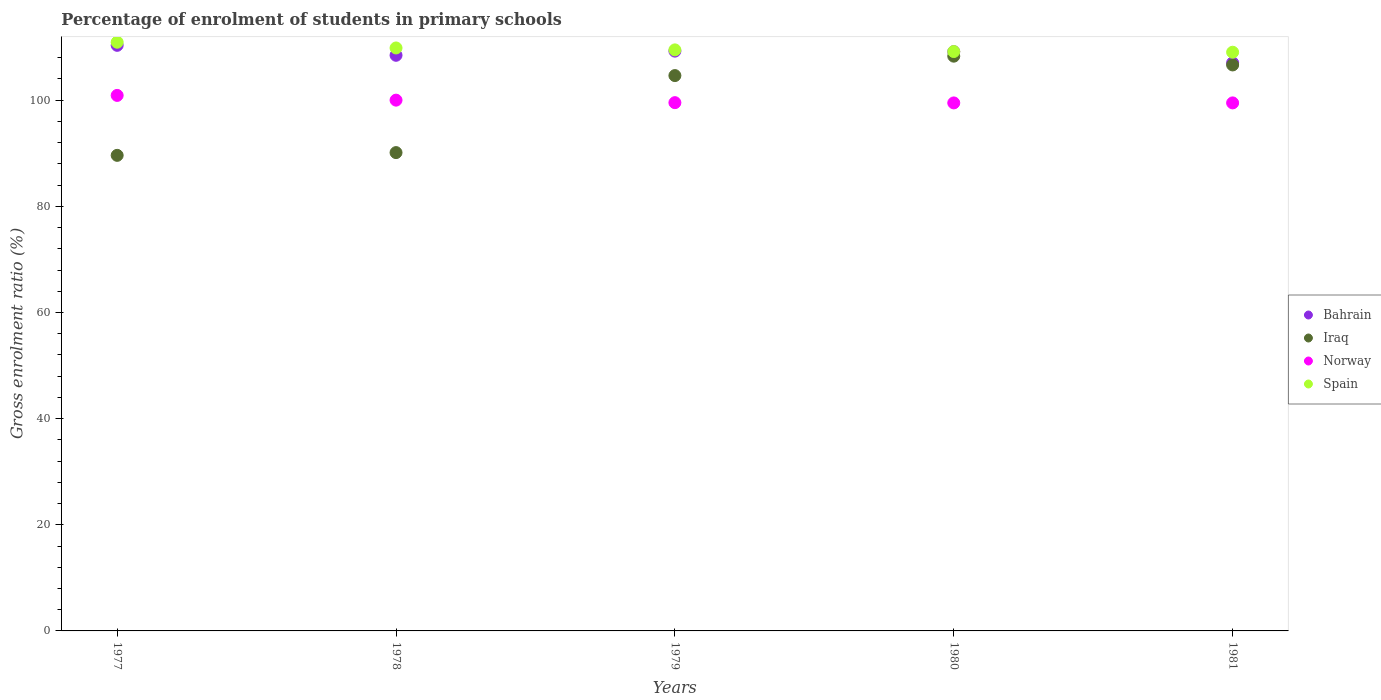What is the percentage of students enrolled in primary schools in Iraq in 1979?
Make the answer very short. 104.64. Across all years, what is the maximum percentage of students enrolled in primary schools in Bahrain?
Offer a terse response. 110.34. Across all years, what is the minimum percentage of students enrolled in primary schools in Norway?
Keep it short and to the point. 99.49. What is the total percentage of students enrolled in primary schools in Spain in the graph?
Ensure brevity in your answer.  548.46. What is the difference between the percentage of students enrolled in primary schools in Norway in 1977 and that in 1980?
Ensure brevity in your answer.  1.42. What is the difference between the percentage of students enrolled in primary schools in Spain in 1980 and the percentage of students enrolled in primary schools in Norway in 1977?
Provide a short and direct response. 8.27. What is the average percentage of students enrolled in primary schools in Bahrain per year?
Your answer should be compact. 108.85. In the year 1980, what is the difference between the percentage of students enrolled in primary schools in Bahrain and percentage of students enrolled in primary schools in Spain?
Keep it short and to the point. -0.02. What is the ratio of the percentage of students enrolled in primary schools in Bahrain in 1980 to that in 1981?
Keep it short and to the point. 1.02. Is the percentage of students enrolled in primary schools in Bahrain in 1980 less than that in 1981?
Provide a succinct answer. No. Is the difference between the percentage of students enrolled in primary schools in Bahrain in 1980 and 1981 greater than the difference between the percentage of students enrolled in primary schools in Spain in 1980 and 1981?
Give a very brief answer. Yes. What is the difference between the highest and the second highest percentage of students enrolled in primary schools in Bahrain?
Provide a short and direct response. 1.09. What is the difference between the highest and the lowest percentage of students enrolled in primary schools in Spain?
Make the answer very short. 1.88. Is the sum of the percentage of students enrolled in primary schools in Norway in 1979 and 1981 greater than the maximum percentage of students enrolled in primary schools in Iraq across all years?
Your response must be concise. Yes. Is it the case that in every year, the sum of the percentage of students enrolled in primary schools in Norway and percentage of students enrolled in primary schools in Iraq  is greater than the sum of percentage of students enrolled in primary schools in Spain and percentage of students enrolled in primary schools in Bahrain?
Provide a short and direct response. No. Does the percentage of students enrolled in primary schools in Bahrain monotonically increase over the years?
Ensure brevity in your answer.  No. Is the percentage of students enrolled in primary schools in Bahrain strictly greater than the percentage of students enrolled in primary schools in Spain over the years?
Your answer should be compact. No. How many dotlines are there?
Your answer should be compact. 4. Are the values on the major ticks of Y-axis written in scientific E-notation?
Keep it short and to the point. No. Does the graph contain any zero values?
Offer a terse response. No. Where does the legend appear in the graph?
Provide a short and direct response. Center right. How are the legend labels stacked?
Your answer should be compact. Vertical. What is the title of the graph?
Provide a succinct answer. Percentage of enrolment of students in primary schools. Does "Serbia" appear as one of the legend labels in the graph?
Your answer should be compact. No. What is the label or title of the X-axis?
Your response must be concise. Years. What is the label or title of the Y-axis?
Keep it short and to the point. Gross enrolment ratio (%). What is the Gross enrolment ratio (%) in Bahrain in 1977?
Ensure brevity in your answer.  110.34. What is the Gross enrolment ratio (%) of Iraq in 1977?
Your answer should be compact. 89.61. What is the Gross enrolment ratio (%) of Norway in 1977?
Your response must be concise. 100.9. What is the Gross enrolment ratio (%) in Spain in 1977?
Offer a very short reply. 110.92. What is the Gross enrolment ratio (%) in Bahrain in 1978?
Your response must be concise. 108.46. What is the Gross enrolment ratio (%) in Iraq in 1978?
Your response must be concise. 90.13. What is the Gross enrolment ratio (%) of Norway in 1978?
Offer a terse response. 100.01. What is the Gross enrolment ratio (%) of Spain in 1978?
Your answer should be very brief. 109.84. What is the Gross enrolment ratio (%) in Bahrain in 1979?
Keep it short and to the point. 109.25. What is the Gross enrolment ratio (%) in Iraq in 1979?
Your answer should be compact. 104.64. What is the Gross enrolment ratio (%) of Norway in 1979?
Give a very brief answer. 99.54. What is the Gross enrolment ratio (%) of Spain in 1979?
Your answer should be compact. 109.48. What is the Gross enrolment ratio (%) in Bahrain in 1980?
Your response must be concise. 109.15. What is the Gross enrolment ratio (%) of Iraq in 1980?
Keep it short and to the point. 108.3. What is the Gross enrolment ratio (%) in Norway in 1980?
Your response must be concise. 99.49. What is the Gross enrolment ratio (%) in Spain in 1980?
Provide a succinct answer. 109.17. What is the Gross enrolment ratio (%) in Bahrain in 1981?
Ensure brevity in your answer.  107.04. What is the Gross enrolment ratio (%) in Iraq in 1981?
Give a very brief answer. 106.65. What is the Gross enrolment ratio (%) of Norway in 1981?
Ensure brevity in your answer.  99.49. What is the Gross enrolment ratio (%) in Spain in 1981?
Offer a very short reply. 109.04. Across all years, what is the maximum Gross enrolment ratio (%) of Bahrain?
Ensure brevity in your answer.  110.34. Across all years, what is the maximum Gross enrolment ratio (%) of Iraq?
Your response must be concise. 108.3. Across all years, what is the maximum Gross enrolment ratio (%) in Norway?
Give a very brief answer. 100.9. Across all years, what is the maximum Gross enrolment ratio (%) of Spain?
Provide a short and direct response. 110.92. Across all years, what is the minimum Gross enrolment ratio (%) in Bahrain?
Your answer should be compact. 107.04. Across all years, what is the minimum Gross enrolment ratio (%) in Iraq?
Provide a short and direct response. 89.61. Across all years, what is the minimum Gross enrolment ratio (%) of Norway?
Provide a succinct answer. 99.49. Across all years, what is the minimum Gross enrolment ratio (%) in Spain?
Give a very brief answer. 109.04. What is the total Gross enrolment ratio (%) of Bahrain in the graph?
Keep it short and to the point. 544.24. What is the total Gross enrolment ratio (%) in Iraq in the graph?
Give a very brief answer. 499.32. What is the total Gross enrolment ratio (%) in Norway in the graph?
Your response must be concise. 499.44. What is the total Gross enrolment ratio (%) in Spain in the graph?
Keep it short and to the point. 548.46. What is the difference between the Gross enrolment ratio (%) of Bahrain in 1977 and that in 1978?
Ensure brevity in your answer.  1.88. What is the difference between the Gross enrolment ratio (%) of Iraq in 1977 and that in 1978?
Your response must be concise. -0.52. What is the difference between the Gross enrolment ratio (%) in Norway in 1977 and that in 1978?
Give a very brief answer. 0.89. What is the difference between the Gross enrolment ratio (%) in Spain in 1977 and that in 1978?
Keep it short and to the point. 1.08. What is the difference between the Gross enrolment ratio (%) of Bahrain in 1977 and that in 1979?
Keep it short and to the point. 1.09. What is the difference between the Gross enrolment ratio (%) in Iraq in 1977 and that in 1979?
Provide a succinct answer. -15.03. What is the difference between the Gross enrolment ratio (%) in Norway in 1977 and that in 1979?
Your answer should be very brief. 1.37. What is the difference between the Gross enrolment ratio (%) of Spain in 1977 and that in 1979?
Offer a very short reply. 1.44. What is the difference between the Gross enrolment ratio (%) in Bahrain in 1977 and that in 1980?
Make the answer very short. 1.19. What is the difference between the Gross enrolment ratio (%) in Iraq in 1977 and that in 1980?
Keep it short and to the point. -18.69. What is the difference between the Gross enrolment ratio (%) of Norway in 1977 and that in 1980?
Your response must be concise. 1.42. What is the difference between the Gross enrolment ratio (%) in Spain in 1977 and that in 1980?
Provide a short and direct response. 1.75. What is the difference between the Gross enrolment ratio (%) of Bahrain in 1977 and that in 1981?
Your response must be concise. 3.3. What is the difference between the Gross enrolment ratio (%) in Iraq in 1977 and that in 1981?
Make the answer very short. -17.04. What is the difference between the Gross enrolment ratio (%) of Norway in 1977 and that in 1981?
Your response must be concise. 1.41. What is the difference between the Gross enrolment ratio (%) in Spain in 1977 and that in 1981?
Your answer should be very brief. 1.88. What is the difference between the Gross enrolment ratio (%) in Bahrain in 1978 and that in 1979?
Your response must be concise. -0.78. What is the difference between the Gross enrolment ratio (%) of Iraq in 1978 and that in 1979?
Your answer should be compact. -14.51. What is the difference between the Gross enrolment ratio (%) of Norway in 1978 and that in 1979?
Ensure brevity in your answer.  0.47. What is the difference between the Gross enrolment ratio (%) in Spain in 1978 and that in 1979?
Offer a terse response. 0.36. What is the difference between the Gross enrolment ratio (%) in Bahrain in 1978 and that in 1980?
Offer a terse response. -0.68. What is the difference between the Gross enrolment ratio (%) in Iraq in 1978 and that in 1980?
Make the answer very short. -18.17. What is the difference between the Gross enrolment ratio (%) in Norway in 1978 and that in 1980?
Your answer should be very brief. 0.52. What is the difference between the Gross enrolment ratio (%) in Spain in 1978 and that in 1980?
Offer a very short reply. 0.67. What is the difference between the Gross enrolment ratio (%) of Bahrain in 1978 and that in 1981?
Make the answer very short. 1.42. What is the difference between the Gross enrolment ratio (%) of Iraq in 1978 and that in 1981?
Keep it short and to the point. -16.52. What is the difference between the Gross enrolment ratio (%) of Norway in 1978 and that in 1981?
Your answer should be compact. 0.52. What is the difference between the Gross enrolment ratio (%) of Spain in 1978 and that in 1981?
Keep it short and to the point. 0.8. What is the difference between the Gross enrolment ratio (%) in Bahrain in 1979 and that in 1980?
Ensure brevity in your answer.  0.1. What is the difference between the Gross enrolment ratio (%) of Iraq in 1979 and that in 1980?
Make the answer very short. -3.66. What is the difference between the Gross enrolment ratio (%) of Norway in 1979 and that in 1980?
Your response must be concise. 0.05. What is the difference between the Gross enrolment ratio (%) in Spain in 1979 and that in 1980?
Keep it short and to the point. 0.31. What is the difference between the Gross enrolment ratio (%) of Bahrain in 1979 and that in 1981?
Your answer should be compact. 2.2. What is the difference between the Gross enrolment ratio (%) in Iraq in 1979 and that in 1981?
Your answer should be very brief. -2. What is the difference between the Gross enrolment ratio (%) of Norway in 1979 and that in 1981?
Offer a terse response. 0.05. What is the difference between the Gross enrolment ratio (%) in Spain in 1979 and that in 1981?
Keep it short and to the point. 0.44. What is the difference between the Gross enrolment ratio (%) of Bahrain in 1980 and that in 1981?
Offer a terse response. 2.1. What is the difference between the Gross enrolment ratio (%) in Iraq in 1980 and that in 1981?
Your response must be concise. 1.65. What is the difference between the Gross enrolment ratio (%) in Norway in 1980 and that in 1981?
Provide a short and direct response. -0. What is the difference between the Gross enrolment ratio (%) of Spain in 1980 and that in 1981?
Provide a short and direct response. 0.13. What is the difference between the Gross enrolment ratio (%) in Bahrain in 1977 and the Gross enrolment ratio (%) in Iraq in 1978?
Give a very brief answer. 20.21. What is the difference between the Gross enrolment ratio (%) in Bahrain in 1977 and the Gross enrolment ratio (%) in Norway in 1978?
Make the answer very short. 10.33. What is the difference between the Gross enrolment ratio (%) of Bahrain in 1977 and the Gross enrolment ratio (%) of Spain in 1978?
Keep it short and to the point. 0.5. What is the difference between the Gross enrolment ratio (%) of Iraq in 1977 and the Gross enrolment ratio (%) of Norway in 1978?
Provide a succinct answer. -10.4. What is the difference between the Gross enrolment ratio (%) in Iraq in 1977 and the Gross enrolment ratio (%) in Spain in 1978?
Your response must be concise. -20.24. What is the difference between the Gross enrolment ratio (%) of Norway in 1977 and the Gross enrolment ratio (%) of Spain in 1978?
Provide a short and direct response. -8.94. What is the difference between the Gross enrolment ratio (%) in Bahrain in 1977 and the Gross enrolment ratio (%) in Iraq in 1979?
Make the answer very short. 5.7. What is the difference between the Gross enrolment ratio (%) in Bahrain in 1977 and the Gross enrolment ratio (%) in Norway in 1979?
Ensure brevity in your answer.  10.8. What is the difference between the Gross enrolment ratio (%) in Bahrain in 1977 and the Gross enrolment ratio (%) in Spain in 1979?
Your response must be concise. 0.86. What is the difference between the Gross enrolment ratio (%) in Iraq in 1977 and the Gross enrolment ratio (%) in Norway in 1979?
Your answer should be very brief. -9.93. What is the difference between the Gross enrolment ratio (%) of Iraq in 1977 and the Gross enrolment ratio (%) of Spain in 1979?
Your response must be concise. -19.87. What is the difference between the Gross enrolment ratio (%) in Norway in 1977 and the Gross enrolment ratio (%) in Spain in 1979?
Offer a very short reply. -8.58. What is the difference between the Gross enrolment ratio (%) in Bahrain in 1977 and the Gross enrolment ratio (%) in Iraq in 1980?
Your answer should be very brief. 2.04. What is the difference between the Gross enrolment ratio (%) in Bahrain in 1977 and the Gross enrolment ratio (%) in Norway in 1980?
Provide a succinct answer. 10.85. What is the difference between the Gross enrolment ratio (%) of Bahrain in 1977 and the Gross enrolment ratio (%) of Spain in 1980?
Offer a very short reply. 1.17. What is the difference between the Gross enrolment ratio (%) of Iraq in 1977 and the Gross enrolment ratio (%) of Norway in 1980?
Your answer should be compact. -9.88. What is the difference between the Gross enrolment ratio (%) in Iraq in 1977 and the Gross enrolment ratio (%) in Spain in 1980?
Ensure brevity in your answer.  -19.56. What is the difference between the Gross enrolment ratio (%) in Norway in 1977 and the Gross enrolment ratio (%) in Spain in 1980?
Ensure brevity in your answer.  -8.27. What is the difference between the Gross enrolment ratio (%) of Bahrain in 1977 and the Gross enrolment ratio (%) of Iraq in 1981?
Make the answer very short. 3.69. What is the difference between the Gross enrolment ratio (%) in Bahrain in 1977 and the Gross enrolment ratio (%) in Norway in 1981?
Keep it short and to the point. 10.85. What is the difference between the Gross enrolment ratio (%) of Bahrain in 1977 and the Gross enrolment ratio (%) of Spain in 1981?
Your response must be concise. 1.3. What is the difference between the Gross enrolment ratio (%) in Iraq in 1977 and the Gross enrolment ratio (%) in Norway in 1981?
Your response must be concise. -9.88. What is the difference between the Gross enrolment ratio (%) in Iraq in 1977 and the Gross enrolment ratio (%) in Spain in 1981?
Your answer should be compact. -19.43. What is the difference between the Gross enrolment ratio (%) in Norway in 1977 and the Gross enrolment ratio (%) in Spain in 1981?
Keep it short and to the point. -8.14. What is the difference between the Gross enrolment ratio (%) in Bahrain in 1978 and the Gross enrolment ratio (%) in Iraq in 1979?
Offer a terse response. 3.82. What is the difference between the Gross enrolment ratio (%) in Bahrain in 1978 and the Gross enrolment ratio (%) in Norway in 1979?
Your response must be concise. 8.93. What is the difference between the Gross enrolment ratio (%) of Bahrain in 1978 and the Gross enrolment ratio (%) of Spain in 1979?
Keep it short and to the point. -1.02. What is the difference between the Gross enrolment ratio (%) in Iraq in 1978 and the Gross enrolment ratio (%) in Norway in 1979?
Your response must be concise. -9.41. What is the difference between the Gross enrolment ratio (%) in Iraq in 1978 and the Gross enrolment ratio (%) in Spain in 1979?
Provide a short and direct response. -19.35. What is the difference between the Gross enrolment ratio (%) in Norway in 1978 and the Gross enrolment ratio (%) in Spain in 1979?
Make the answer very short. -9.47. What is the difference between the Gross enrolment ratio (%) in Bahrain in 1978 and the Gross enrolment ratio (%) in Iraq in 1980?
Your response must be concise. 0.16. What is the difference between the Gross enrolment ratio (%) of Bahrain in 1978 and the Gross enrolment ratio (%) of Norway in 1980?
Ensure brevity in your answer.  8.97. What is the difference between the Gross enrolment ratio (%) of Bahrain in 1978 and the Gross enrolment ratio (%) of Spain in 1980?
Keep it short and to the point. -0.71. What is the difference between the Gross enrolment ratio (%) of Iraq in 1978 and the Gross enrolment ratio (%) of Norway in 1980?
Provide a short and direct response. -9.36. What is the difference between the Gross enrolment ratio (%) in Iraq in 1978 and the Gross enrolment ratio (%) in Spain in 1980?
Offer a terse response. -19.04. What is the difference between the Gross enrolment ratio (%) in Norway in 1978 and the Gross enrolment ratio (%) in Spain in 1980?
Your answer should be very brief. -9.16. What is the difference between the Gross enrolment ratio (%) of Bahrain in 1978 and the Gross enrolment ratio (%) of Iraq in 1981?
Your answer should be very brief. 1.82. What is the difference between the Gross enrolment ratio (%) in Bahrain in 1978 and the Gross enrolment ratio (%) in Norway in 1981?
Give a very brief answer. 8.97. What is the difference between the Gross enrolment ratio (%) of Bahrain in 1978 and the Gross enrolment ratio (%) of Spain in 1981?
Your answer should be compact. -0.58. What is the difference between the Gross enrolment ratio (%) of Iraq in 1978 and the Gross enrolment ratio (%) of Norway in 1981?
Offer a very short reply. -9.36. What is the difference between the Gross enrolment ratio (%) of Iraq in 1978 and the Gross enrolment ratio (%) of Spain in 1981?
Provide a short and direct response. -18.91. What is the difference between the Gross enrolment ratio (%) in Norway in 1978 and the Gross enrolment ratio (%) in Spain in 1981?
Your response must be concise. -9.03. What is the difference between the Gross enrolment ratio (%) of Bahrain in 1979 and the Gross enrolment ratio (%) of Iraq in 1980?
Keep it short and to the point. 0.95. What is the difference between the Gross enrolment ratio (%) of Bahrain in 1979 and the Gross enrolment ratio (%) of Norway in 1980?
Your answer should be compact. 9.76. What is the difference between the Gross enrolment ratio (%) of Bahrain in 1979 and the Gross enrolment ratio (%) of Spain in 1980?
Your answer should be compact. 0.08. What is the difference between the Gross enrolment ratio (%) of Iraq in 1979 and the Gross enrolment ratio (%) of Norway in 1980?
Keep it short and to the point. 5.15. What is the difference between the Gross enrolment ratio (%) of Iraq in 1979 and the Gross enrolment ratio (%) of Spain in 1980?
Provide a short and direct response. -4.53. What is the difference between the Gross enrolment ratio (%) of Norway in 1979 and the Gross enrolment ratio (%) of Spain in 1980?
Your answer should be compact. -9.63. What is the difference between the Gross enrolment ratio (%) in Bahrain in 1979 and the Gross enrolment ratio (%) in Iraq in 1981?
Keep it short and to the point. 2.6. What is the difference between the Gross enrolment ratio (%) in Bahrain in 1979 and the Gross enrolment ratio (%) in Norway in 1981?
Give a very brief answer. 9.75. What is the difference between the Gross enrolment ratio (%) of Bahrain in 1979 and the Gross enrolment ratio (%) of Spain in 1981?
Offer a terse response. 0.21. What is the difference between the Gross enrolment ratio (%) of Iraq in 1979 and the Gross enrolment ratio (%) of Norway in 1981?
Give a very brief answer. 5.15. What is the difference between the Gross enrolment ratio (%) of Iraq in 1979 and the Gross enrolment ratio (%) of Spain in 1981?
Your answer should be very brief. -4.4. What is the difference between the Gross enrolment ratio (%) of Norway in 1979 and the Gross enrolment ratio (%) of Spain in 1981?
Your response must be concise. -9.5. What is the difference between the Gross enrolment ratio (%) of Bahrain in 1980 and the Gross enrolment ratio (%) of Iraq in 1981?
Provide a short and direct response. 2.5. What is the difference between the Gross enrolment ratio (%) of Bahrain in 1980 and the Gross enrolment ratio (%) of Norway in 1981?
Ensure brevity in your answer.  9.65. What is the difference between the Gross enrolment ratio (%) in Bahrain in 1980 and the Gross enrolment ratio (%) in Spain in 1981?
Ensure brevity in your answer.  0.11. What is the difference between the Gross enrolment ratio (%) of Iraq in 1980 and the Gross enrolment ratio (%) of Norway in 1981?
Your response must be concise. 8.81. What is the difference between the Gross enrolment ratio (%) of Iraq in 1980 and the Gross enrolment ratio (%) of Spain in 1981?
Offer a very short reply. -0.74. What is the difference between the Gross enrolment ratio (%) in Norway in 1980 and the Gross enrolment ratio (%) in Spain in 1981?
Your answer should be very brief. -9.55. What is the average Gross enrolment ratio (%) of Bahrain per year?
Offer a very short reply. 108.85. What is the average Gross enrolment ratio (%) of Iraq per year?
Your response must be concise. 99.86. What is the average Gross enrolment ratio (%) in Norway per year?
Your response must be concise. 99.89. What is the average Gross enrolment ratio (%) of Spain per year?
Your response must be concise. 109.69. In the year 1977, what is the difference between the Gross enrolment ratio (%) of Bahrain and Gross enrolment ratio (%) of Iraq?
Provide a short and direct response. 20.73. In the year 1977, what is the difference between the Gross enrolment ratio (%) of Bahrain and Gross enrolment ratio (%) of Norway?
Your answer should be compact. 9.44. In the year 1977, what is the difference between the Gross enrolment ratio (%) in Bahrain and Gross enrolment ratio (%) in Spain?
Your answer should be compact. -0.58. In the year 1977, what is the difference between the Gross enrolment ratio (%) in Iraq and Gross enrolment ratio (%) in Norway?
Make the answer very short. -11.29. In the year 1977, what is the difference between the Gross enrolment ratio (%) in Iraq and Gross enrolment ratio (%) in Spain?
Provide a short and direct response. -21.31. In the year 1977, what is the difference between the Gross enrolment ratio (%) of Norway and Gross enrolment ratio (%) of Spain?
Provide a short and direct response. -10.02. In the year 1978, what is the difference between the Gross enrolment ratio (%) in Bahrain and Gross enrolment ratio (%) in Iraq?
Your response must be concise. 18.34. In the year 1978, what is the difference between the Gross enrolment ratio (%) in Bahrain and Gross enrolment ratio (%) in Norway?
Your answer should be very brief. 8.45. In the year 1978, what is the difference between the Gross enrolment ratio (%) in Bahrain and Gross enrolment ratio (%) in Spain?
Provide a short and direct response. -1.38. In the year 1978, what is the difference between the Gross enrolment ratio (%) in Iraq and Gross enrolment ratio (%) in Norway?
Your response must be concise. -9.88. In the year 1978, what is the difference between the Gross enrolment ratio (%) in Iraq and Gross enrolment ratio (%) in Spain?
Your answer should be very brief. -19.72. In the year 1978, what is the difference between the Gross enrolment ratio (%) of Norway and Gross enrolment ratio (%) of Spain?
Your answer should be compact. -9.83. In the year 1979, what is the difference between the Gross enrolment ratio (%) in Bahrain and Gross enrolment ratio (%) in Iraq?
Your answer should be very brief. 4.61. In the year 1979, what is the difference between the Gross enrolment ratio (%) of Bahrain and Gross enrolment ratio (%) of Norway?
Provide a succinct answer. 9.71. In the year 1979, what is the difference between the Gross enrolment ratio (%) in Bahrain and Gross enrolment ratio (%) in Spain?
Provide a short and direct response. -0.24. In the year 1979, what is the difference between the Gross enrolment ratio (%) in Iraq and Gross enrolment ratio (%) in Norway?
Make the answer very short. 5.1. In the year 1979, what is the difference between the Gross enrolment ratio (%) of Iraq and Gross enrolment ratio (%) of Spain?
Ensure brevity in your answer.  -4.84. In the year 1979, what is the difference between the Gross enrolment ratio (%) in Norway and Gross enrolment ratio (%) in Spain?
Offer a very short reply. -9.94. In the year 1980, what is the difference between the Gross enrolment ratio (%) of Bahrain and Gross enrolment ratio (%) of Iraq?
Give a very brief answer. 0.85. In the year 1980, what is the difference between the Gross enrolment ratio (%) of Bahrain and Gross enrolment ratio (%) of Norway?
Your response must be concise. 9.66. In the year 1980, what is the difference between the Gross enrolment ratio (%) in Bahrain and Gross enrolment ratio (%) in Spain?
Provide a succinct answer. -0.02. In the year 1980, what is the difference between the Gross enrolment ratio (%) in Iraq and Gross enrolment ratio (%) in Norway?
Your response must be concise. 8.81. In the year 1980, what is the difference between the Gross enrolment ratio (%) of Iraq and Gross enrolment ratio (%) of Spain?
Make the answer very short. -0.87. In the year 1980, what is the difference between the Gross enrolment ratio (%) of Norway and Gross enrolment ratio (%) of Spain?
Provide a short and direct response. -9.68. In the year 1981, what is the difference between the Gross enrolment ratio (%) of Bahrain and Gross enrolment ratio (%) of Iraq?
Your answer should be compact. 0.4. In the year 1981, what is the difference between the Gross enrolment ratio (%) of Bahrain and Gross enrolment ratio (%) of Norway?
Keep it short and to the point. 7.55. In the year 1981, what is the difference between the Gross enrolment ratio (%) in Bahrain and Gross enrolment ratio (%) in Spain?
Give a very brief answer. -2. In the year 1981, what is the difference between the Gross enrolment ratio (%) in Iraq and Gross enrolment ratio (%) in Norway?
Make the answer very short. 7.15. In the year 1981, what is the difference between the Gross enrolment ratio (%) in Iraq and Gross enrolment ratio (%) in Spain?
Make the answer very short. -2.4. In the year 1981, what is the difference between the Gross enrolment ratio (%) in Norway and Gross enrolment ratio (%) in Spain?
Give a very brief answer. -9.55. What is the ratio of the Gross enrolment ratio (%) in Bahrain in 1977 to that in 1978?
Offer a very short reply. 1.02. What is the ratio of the Gross enrolment ratio (%) in Iraq in 1977 to that in 1978?
Offer a terse response. 0.99. What is the ratio of the Gross enrolment ratio (%) in Norway in 1977 to that in 1978?
Offer a terse response. 1.01. What is the ratio of the Gross enrolment ratio (%) in Spain in 1977 to that in 1978?
Provide a succinct answer. 1.01. What is the ratio of the Gross enrolment ratio (%) of Iraq in 1977 to that in 1979?
Offer a terse response. 0.86. What is the ratio of the Gross enrolment ratio (%) in Norway in 1977 to that in 1979?
Offer a very short reply. 1.01. What is the ratio of the Gross enrolment ratio (%) in Spain in 1977 to that in 1979?
Offer a terse response. 1.01. What is the ratio of the Gross enrolment ratio (%) of Bahrain in 1977 to that in 1980?
Offer a terse response. 1.01. What is the ratio of the Gross enrolment ratio (%) of Iraq in 1977 to that in 1980?
Make the answer very short. 0.83. What is the ratio of the Gross enrolment ratio (%) in Norway in 1977 to that in 1980?
Ensure brevity in your answer.  1.01. What is the ratio of the Gross enrolment ratio (%) of Spain in 1977 to that in 1980?
Your answer should be very brief. 1.02. What is the ratio of the Gross enrolment ratio (%) of Bahrain in 1977 to that in 1981?
Make the answer very short. 1.03. What is the ratio of the Gross enrolment ratio (%) of Iraq in 1977 to that in 1981?
Provide a short and direct response. 0.84. What is the ratio of the Gross enrolment ratio (%) of Norway in 1977 to that in 1981?
Provide a short and direct response. 1.01. What is the ratio of the Gross enrolment ratio (%) of Spain in 1977 to that in 1981?
Provide a succinct answer. 1.02. What is the ratio of the Gross enrolment ratio (%) in Iraq in 1978 to that in 1979?
Provide a succinct answer. 0.86. What is the ratio of the Gross enrolment ratio (%) of Bahrain in 1978 to that in 1980?
Your answer should be very brief. 0.99. What is the ratio of the Gross enrolment ratio (%) in Iraq in 1978 to that in 1980?
Provide a succinct answer. 0.83. What is the ratio of the Gross enrolment ratio (%) in Norway in 1978 to that in 1980?
Provide a succinct answer. 1.01. What is the ratio of the Gross enrolment ratio (%) in Spain in 1978 to that in 1980?
Offer a very short reply. 1.01. What is the ratio of the Gross enrolment ratio (%) of Bahrain in 1978 to that in 1981?
Make the answer very short. 1.01. What is the ratio of the Gross enrolment ratio (%) in Iraq in 1978 to that in 1981?
Keep it short and to the point. 0.85. What is the ratio of the Gross enrolment ratio (%) in Spain in 1978 to that in 1981?
Offer a terse response. 1.01. What is the ratio of the Gross enrolment ratio (%) in Bahrain in 1979 to that in 1980?
Make the answer very short. 1. What is the ratio of the Gross enrolment ratio (%) of Iraq in 1979 to that in 1980?
Offer a very short reply. 0.97. What is the ratio of the Gross enrolment ratio (%) of Norway in 1979 to that in 1980?
Your answer should be compact. 1. What is the ratio of the Gross enrolment ratio (%) in Spain in 1979 to that in 1980?
Make the answer very short. 1. What is the ratio of the Gross enrolment ratio (%) of Bahrain in 1979 to that in 1981?
Give a very brief answer. 1.02. What is the ratio of the Gross enrolment ratio (%) in Iraq in 1979 to that in 1981?
Make the answer very short. 0.98. What is the ratio of the Gross enrolment ratio (%) in Spain in 1979 to that in 1981?
Provide a short and direct response. 1. What is the ratio of the Gross enrolment ratio (%) of Bahrain in 1980 to that in 1981?
Ensure brevity in your answer.  1.02. What is the ratio of the Gross enrolment ratio (%) of Iraq in 1980 to that in 1981?
Give a very brief answer. 1.02. What is the difference between the highest and the second highest Gross enrolment ratio (%) of Bahrain?
Your response must be concise. 1.09. What is the difference between the highest and the second highest Gross enrolment ratio (%) in Iraq?
Your response must be concise. 1.65. What is the difference between the highest and the second highest Gross enrolment ratio (%) in Norway?
Provide a short and direct response. 0.89. What is the difference between the highest and the second highest Gross enrolment ratio (%) of Spain?
Your answer should be very brief. 1.08. What is the difference between the highest and the lowest Gross enrolment ratio (%) in Bahrain?
Your response must be concise. 3.3. What is the difference between the highest and the lowest Gross enrolment ratio (%) of Iraq?
Give a very brief answer. 18.69. What is the difference between the highest and the lowest Gross enrolment ratio (%) of Norway?
Your answer should be very brief. 1.42. What is the difference between the highest and the lowest Gross enrolment ratio (%) of Spain?
Your answer should be very brief. 1.88. 